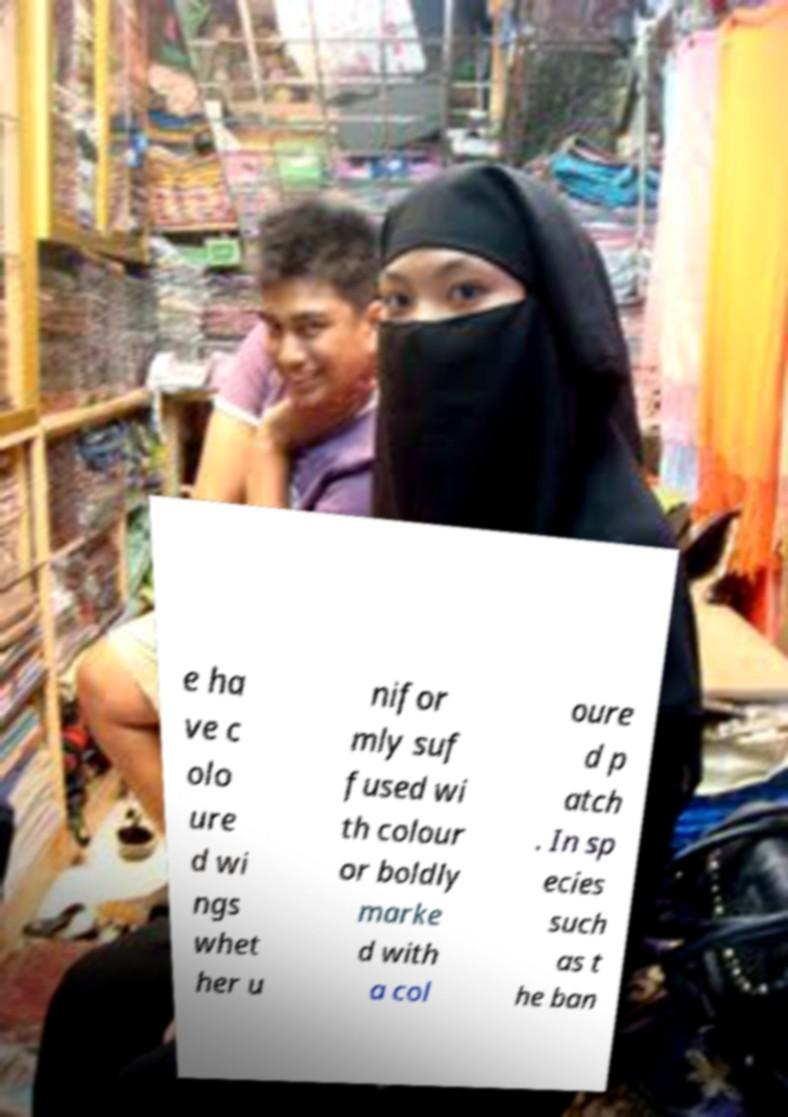Can you accurately transcribe the text from the provided image for me? e ha ve c olo ure d wi ngs whet her u nifor mly suf fused wi th colour or boldly marke d with a col oure d p atch . In sp ecies such as t he ban 